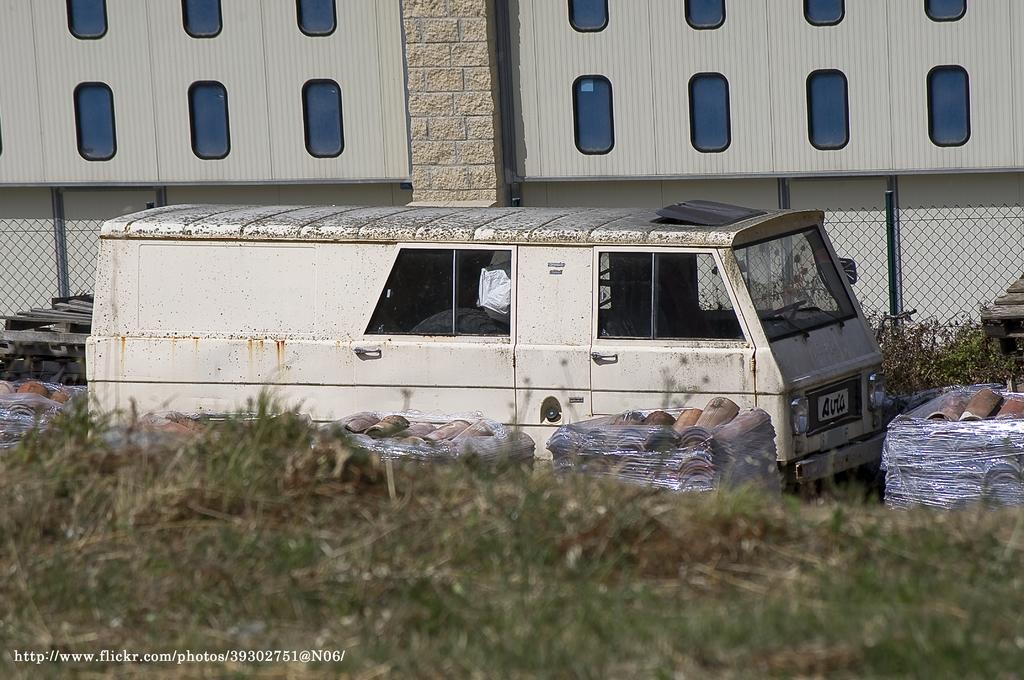What type of vehicle is in the picture? There is a van in the picture. What objects are made of wood and are visible in the image? There are wooden containers in the image. How are the wooden containers being protected or covered? The wooden containers are in polythene bags. What type of vegetation is present on the ground in the image? There is grass on the ground in the image. What type of structure can be seen in the image? There is a building in the image. What type of barrier is present in the image? There is a metal fence in the image. Can you tell me how many pigs are visible in the image? There are no pigs present in the image. What type of musical instrument is being played in the image? There is no musical instrument or any indication of music being played in the image. 